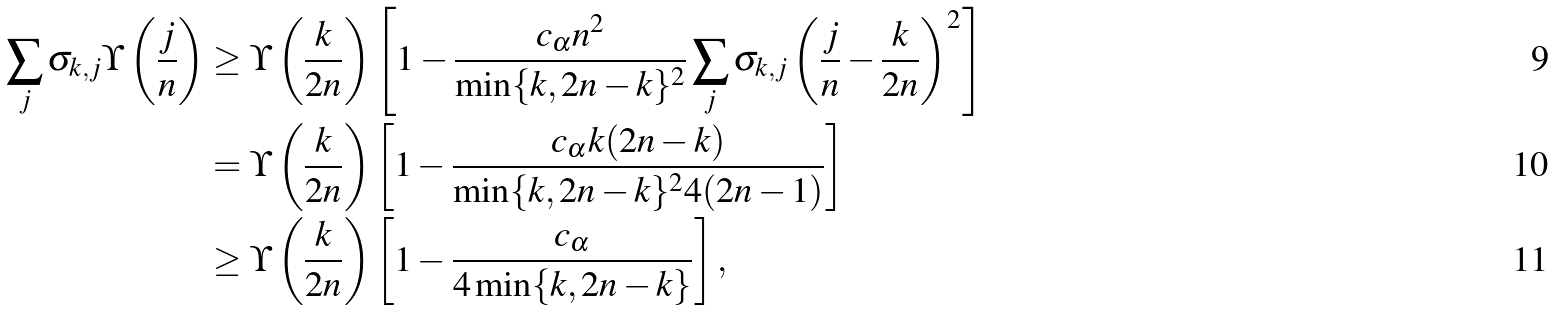<formula> <loc_0><loc_0><loc_500><loc_500>\sum _ { j } \sigma _ { k , j } \Upsilon \left ( \frac { j } { n } \right ) & \geq \Upsilon \left ( \frac { k } { 2 n } \right ) \left [ 1 - \frac { c _ { \alpha } n ^ { 2 } } { \min \{ k , 2 n - k \} ^ { 2 } } \sum _ { j } \sigma _ { k , j } \left ( \frac { j } { n } - \frac { k } { 2 n } \right ) ^ { 2 } \right ] \\ & = \Upsilon \left ( \frac { k } { 2 n } \right ) \left [ 1 - \frac { c _ { \alpha } k ( 2 n - k ) } { \min \{ k , 2 n - k \} ^ { 2 } 4 ( 2 n - 1 ) } \right ] \\ & \geq \Upsilon \left ( \frac { k } { 2 n } \right ) \left [ 1 - \frac { c _ { \alpha } } { 4 \min \{ k , 2 n - k \} } \right ] ,</formula> 